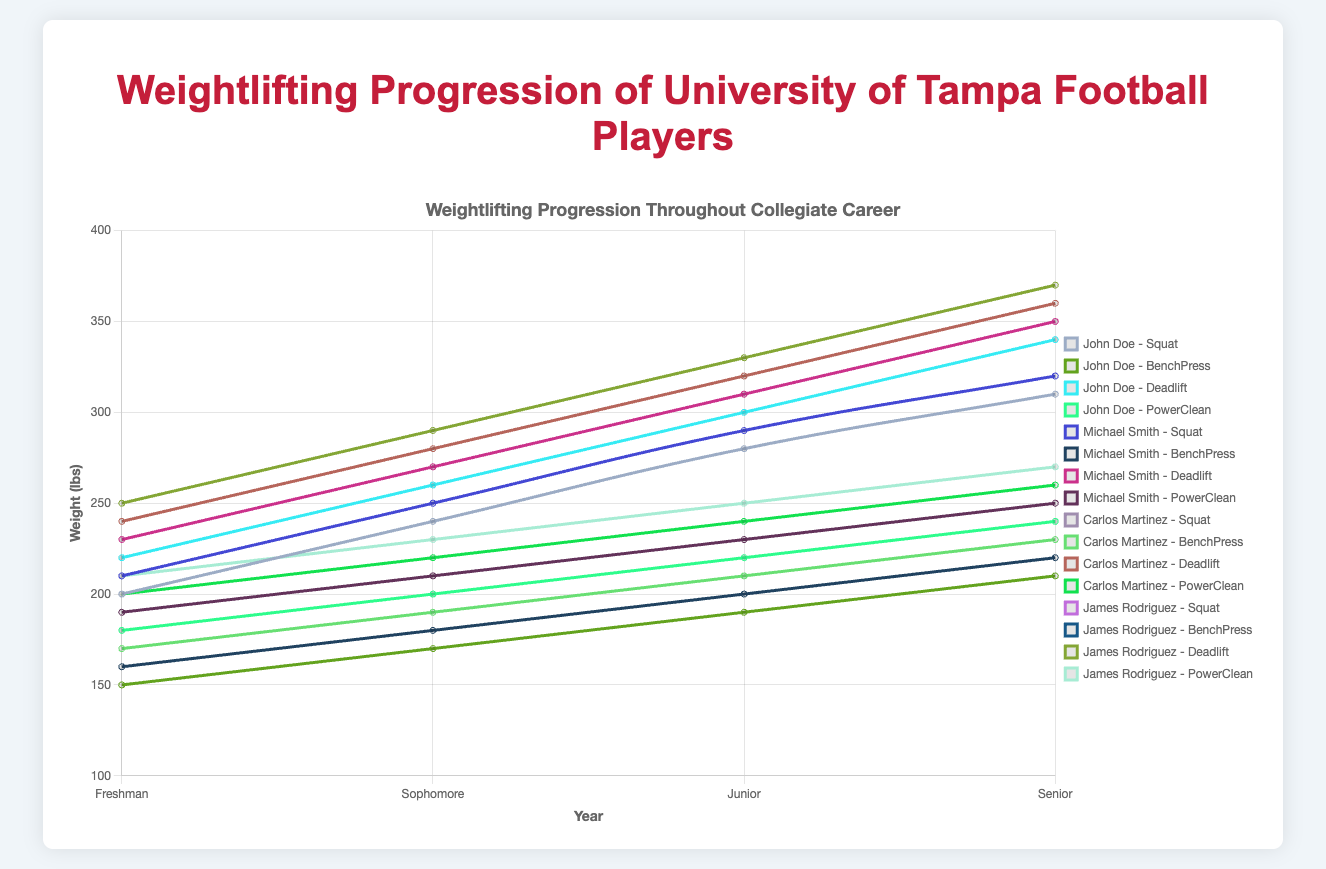what's the average Bench Press weight for Carlos Martinez over his collegiate career? To find the average, sum all of Carlos Martinez's Bench Press weights from Freshman to Senior year (170 + 190 + 210 + 230 = 800) and then divide by the number of years (4). The calculation will be 800/4.
Answer: 200 Which player had the highest Deadlift as a Senior? Look for the Deadlift weights in the Senior year for each player. John Doe has 340 lbs, Michael Smith has 350 lbs, Carlos Martinez has 360 lbs, and James Rodriguez has 370 lbs. James Rodriguez has the highest Deadlift.
Answer: James Rodriguez During which year did John Doe experience the largest increase in Squat weight? Examine the year-over-year increments in John Doe's Squat weights: Sophomore from Freshman (240-200=40), Junior from Sophomore (280-240=40), and Senior from Junior (310-280=30). The largest increase occurred from Freshman to Sophomore year.
Answer: Freshman to Sophomore Who has the highest average increase per year in Power Clean, and what is the amount? Calculate the differences between each year's Power Clean for each player and average them. For example, for John Doe: (200-180=20, 220-200=20, 240-220=20), with an average of 20 lbs/year. Repeat for other players and compare.
Answer: James Rodriguez, 20 lbs/year What is the difference between the highest and lowest Bench Press weights achieved by Michael Smith over his collegiate career? Look at Michael Smith's Bench Press weights: Freshman (160 lbs), Sophomore (180 lbs), Junior (200 lbs), Senior (220 lbs). The difference is 220-160.
Answer: 60 lbs Whose Deadlift weight increased most consistently over their four years? Examine the Deadlift weights and see which player has the most consistent year-over-year increments. Calculate increments and compare their consistency.
Answer: Michael Smith Between John Doe and Carlos Martinez, who had a higher Power Clean as a Sophomore, and by how much? Compare the Power Clean weights of John Doe and Carlos Martinez in their Sophomore year: John Doe (200 lbs) and Carlos Martinez (220 lbs). Calculate the difference (220-200).
Answer: Carlos Martinez, 20 lbs Which exercise shows the greatest overall increase for James Rodriguez from Freshman to Senior year? Calculate the increase for each exercise: Squat (350-230=120), Bench Press (240-180=60), Deadlift (370-250=120), Power Clean (270-210=60). The Squat and Deadlift have the greatest overall increase.
Answer: Squat and Deadlift, 120 lbs What's the average increase in Bench Press weight from Freshman to Senior year for all players? Find the increase for each player (John Doe: 210-150=60, Michael Smith: 220-160=60, Carlos Martinez: 230-170=60, James Rodriguez: 240-180=60). Average these values (60+60+60+60)/4.
Answer: 60 lbs 